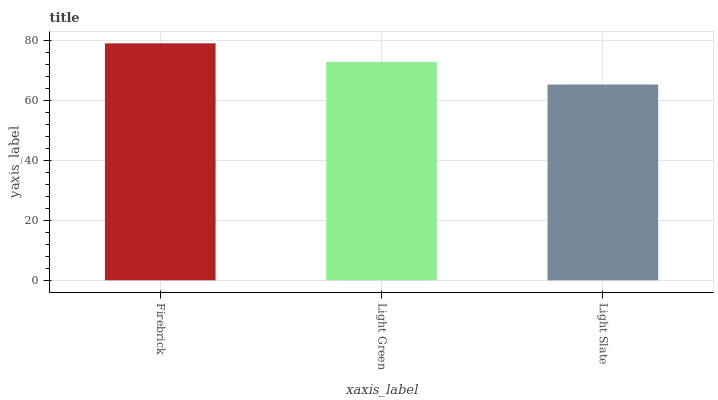Is Light Slate the minimum?
Answer yes or no. Yes. Is Firebrick the maximum?
Answer yes or no. Yes. Is Light Green the minimum?
Answer yes or no. No. Is Light Green the maximum?
Answer yes or no. No. Is Firebrick greater than Light Green?
Answer yes or no. Yes. Is Light Green less than Firebrick?
Answer yes or no. Yes. Is Light Green greater than Firebrick?
Answer yes or no. No. Is Firebrick less than Light Green?
Answer yes or no. No. Is Light Green the high median?
Answer yes or no. Yes. Is Light Green the low median?
Answer yes or no. Yes. Is Light Slate the high median?
Answer yes or no. No. Is Light Slate the low median?
Answer yes or no. No. 